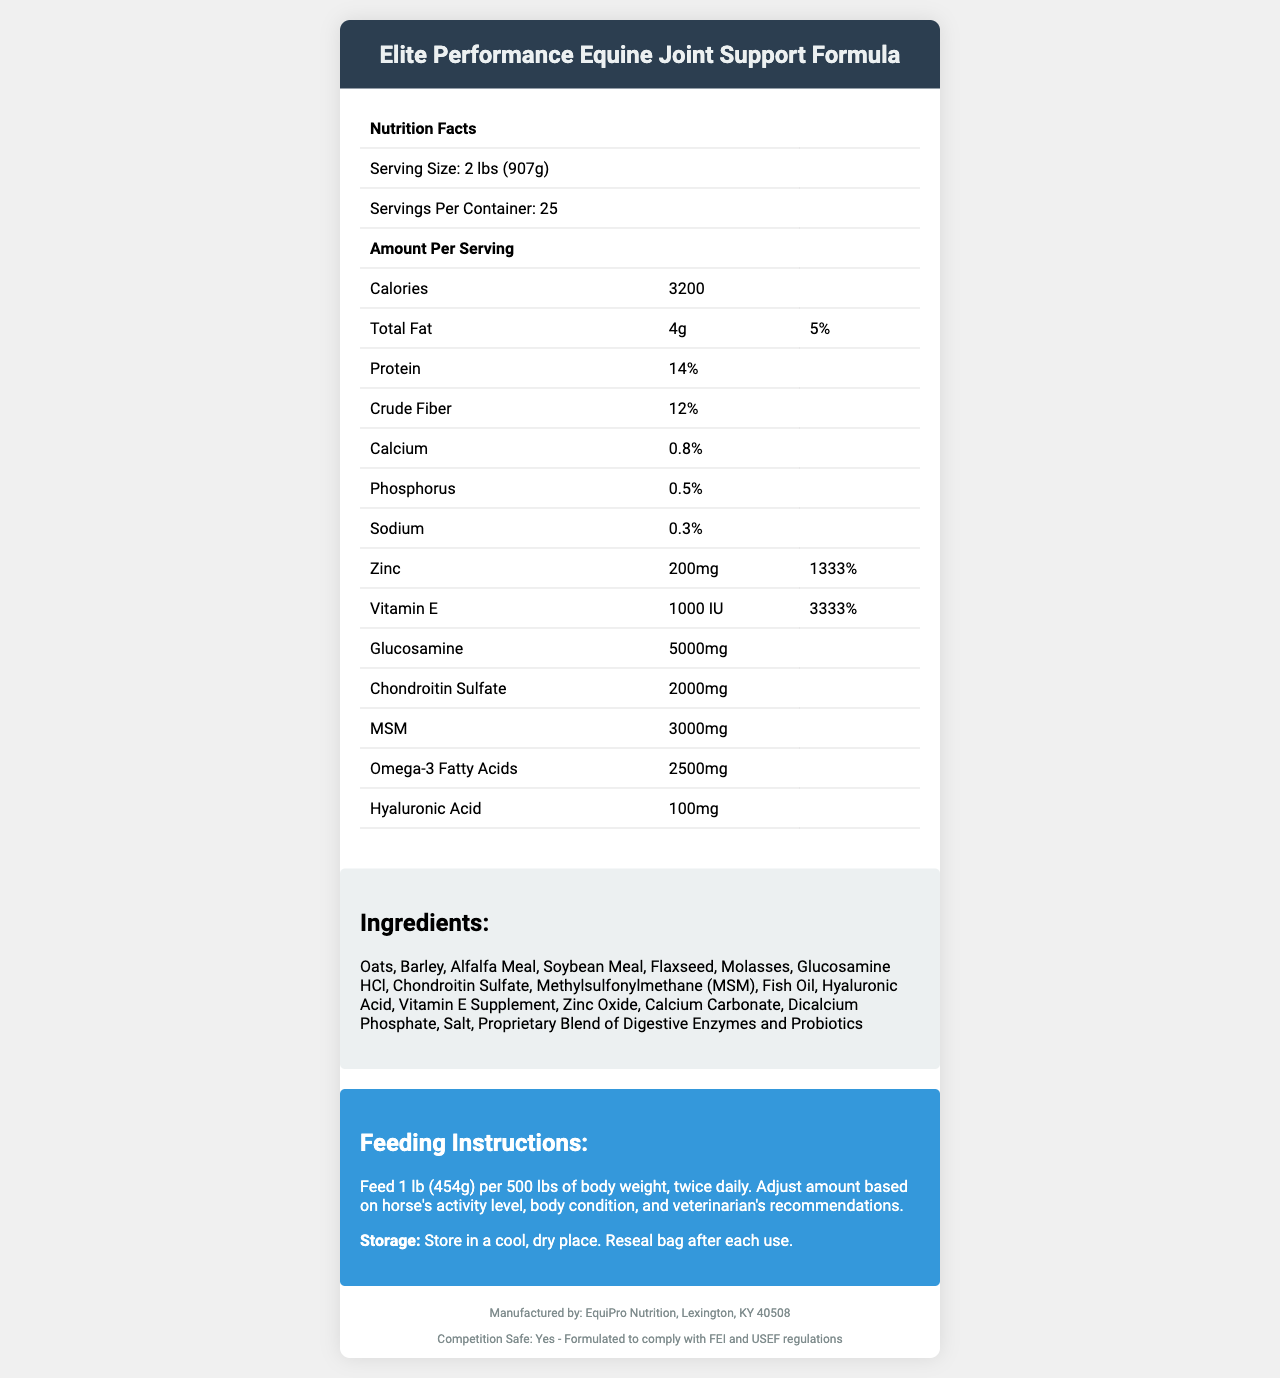who is the manufacturer of the feed? The manufacturer information is explicitly listed in the footer of the document.
Answer: EquiPro Nutrition, Lexington, KY 40508 what is the serving size of the feed? The serving size is clearly mentioned at the beginning of the nutrition facts section.
Answer: 2 lbs (907g) how many calories are there per serving? The calories per serving are listed in the nutrition facts table under "Amount Per Serving."
Answer: 3200 what percentage of daily value does the zinc provide? The daily value percentage for zinc is provided in the nutrition facts section next to the zinc amount.
Answer: 1333% what are the primary ingredients in the feed? The ingredients list is provided in the ingredients section.
Answer: Oats, Barley, Alfalfa Meal, Soybean Meal, Flaxseed, Molasses, Glucosamine HCl, Chondroitin Sulfate, Methylsulfonylmethane (MSM), Fish Oil, Hyaluronic Acid, Vitamin E Supplement, Zinc Oxide, Calcium Carbonate, Dicalcium Phosphate, Salt, Proprietary Blend of Digestive Enzymes and Probiotics which supplement is included in the feed for joint health improvement? A. Omega-3 Fatty Acids B. Glucosamine C. Vitamin E The document lists Glucosamine, Chondroitin Sulfate, and MSM specifically for joint health support in the nutrition facts section.
Answer: B what is the recommended daily feeding instruction for a horse weighing 1000 lbs? The feeding instruction states to feed 1 lb per 500 lbs of body weight twice daily.
Answer: 2 lbs, twice daily True or False: This feed complies with FEI and USEF regulations. The document states "Competition Safe: Yes - Formulated to comply with FEI and USEF regulations" in the footer.
Answer: True summarize the main idea of the document. This is a high-level summary that encompasses the key components of the document including nutritional content, special ingredients, feeding guidelines, and regulatory compliance.
Answer: The document provides detailed nutrition facts, ingredients, feeding instructions, and other relevant information about the Elite Performance Equine Joint Support Formula, which is designed to support the overall health and joint function of horses. The feed includes various supplements like Glucosamine, Chondroitin Sulfate, and MSM, and adheres to FEI and USEF competition regulations. what percentage of daily value does the protein provide? The document does not provide the daily value percentage for protein, only the amount (14%).
Answer: Not enough information does this feed contain Vitamin D? The document lists Vitamin E but does not mention Vitamin D in the nutrition facts or ingredients.
Answer: No what is the total crude fiber content in the feed? The crude fiber content is listed in the nutrition facts section.
Answer: 12% how should the feed be stored to maintain its quality? The storage instructions are outlined in the feeding instructions section.
Answer: Store in a cool, dry place. Reseal bag after each use. which supplement in the feed has the highest amount per serving? A. Glucosamine B. Chondroitin Sulfate C. MSM Glucosamine is provided in the amount of 5000mg per serving, which is higher than Chondroitin Sulfate (2000mg) and MSM (3000mg).
Answer: A is the feeding amount adjusted based on activity level and body condition? The feeding instructions specify that the amount should be adjusted based on the horse's activity level, body condition, and veterinarian's recommendations.
Answer: Yes 